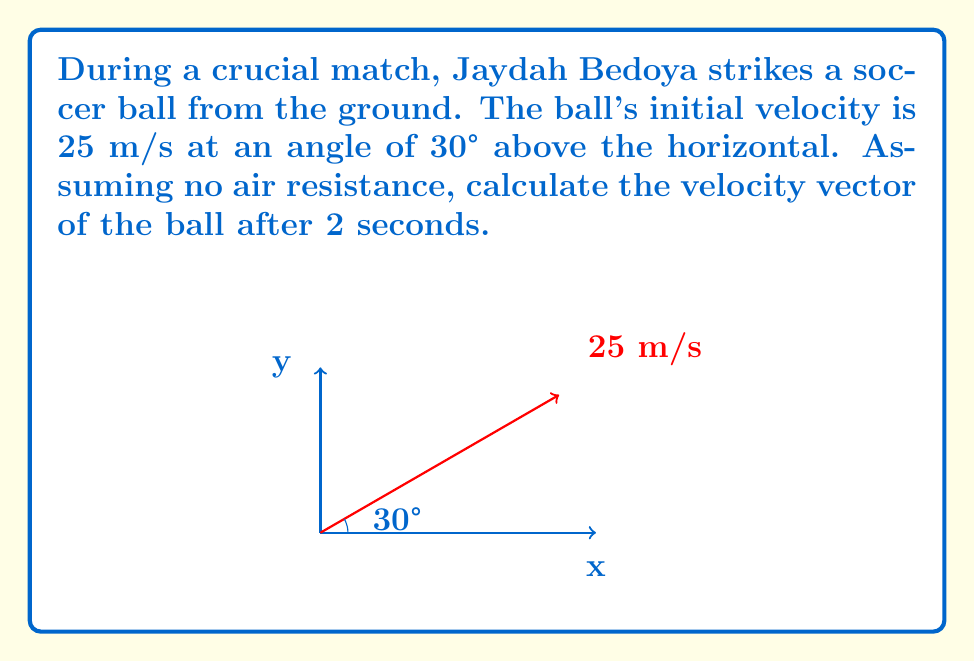Can you answer this question? To solve this problem, we'll use the equations of motion for projectile motion:

1) Initial velocity components:
   $v_{0x} = v_0 \cos \theta = 25 \cos 30° = 21.65$ m/s
   $v_{0y} = v_0 \sin \theta = 25 \sin 30° = 12.5$ m/s

2) After time $t$, the velocity components are:
   $v_x = v_{0x}$ (constant in x-direction)
   $v_y = v_{0y} - gt$ (g = 9.8 m/s²)

3) Calculate $v_y$ after 2 seconds:
   $v_y = 12.5 - 9.8(2) = -7.1$ m/s

4) The velocity vector after 2 seconds is:
   $\vec{v} = (21.65\hat{i} - 7.1\hat{j})$ m/s

5) Magnitude of the velocity:
   $|\vec{v}| = \sqrt{21.65^2 + (-7.1)^2} = 22.8$ m/s

6) Angle with horizontal:
   $\theta = \tan^{-1}(\frac{-7.1}{21.65}) = -18.2°$

The negative angle indicates the ball is moving downward after 2 seconds.
Answer: $\vec{v} = (21.65\hat{i} - 7.1\hat{j})$ m/s 